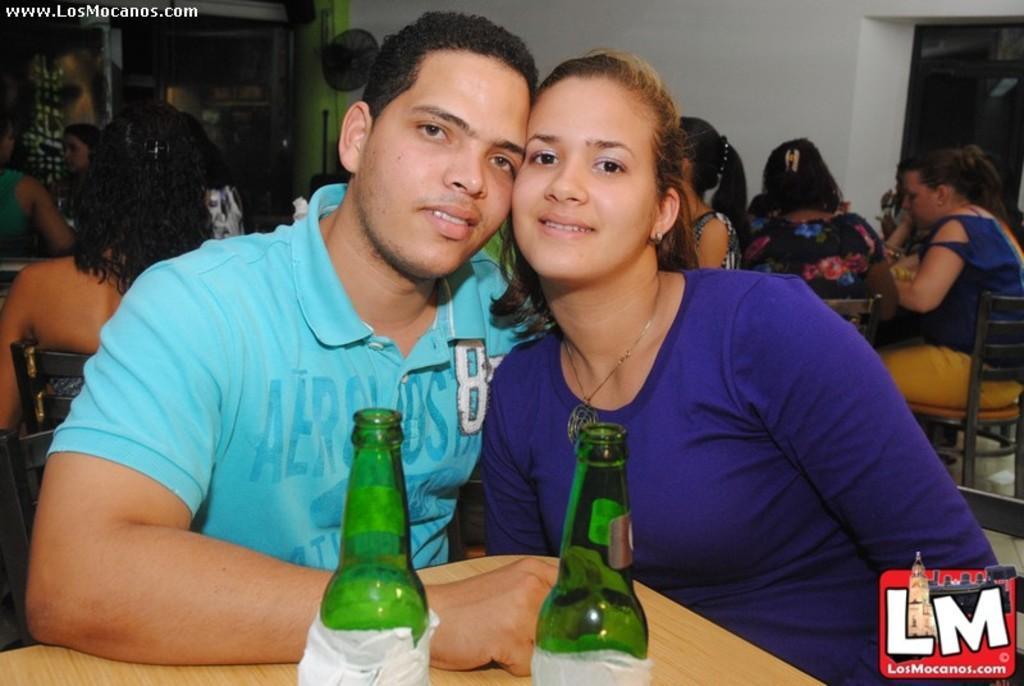Could you give a brief overview of what you see in this image? This picture there is a man and woman sitting on the chair, there is a table in front of them, with two beer bottles kept on it and in the backdrop there are few women sitting here and and there are some other people sitting over here and in the background there is a door and there's a wall. 